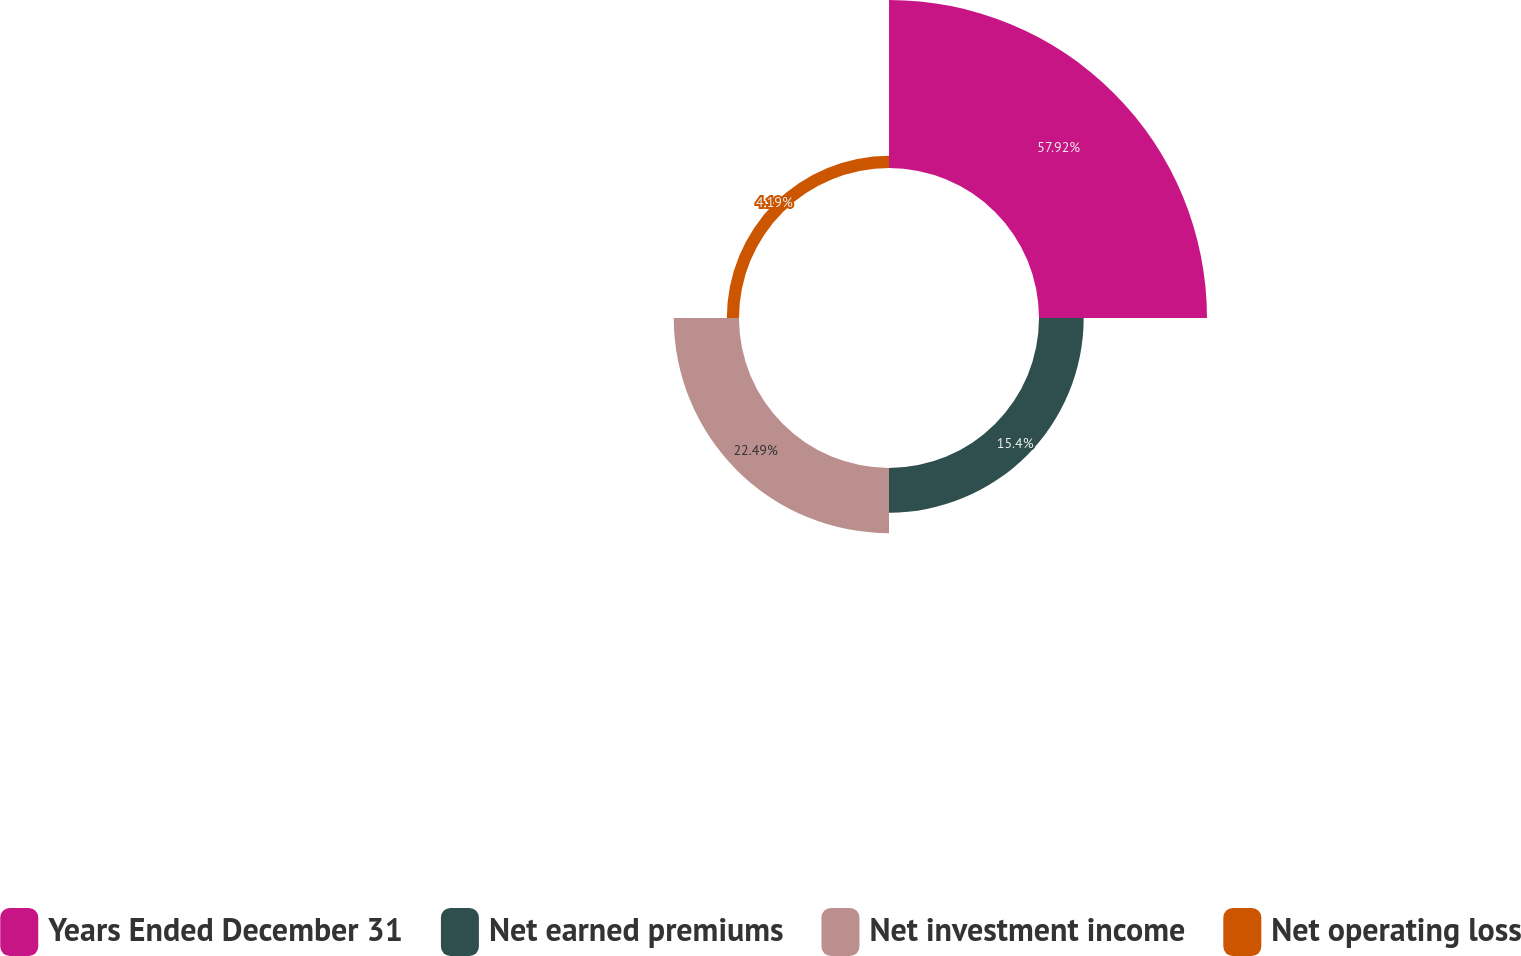Convert chart. <chart><loc_0><loc_0><loc_500><loc_500><pie_chart><fcel>Years Ended December 31<fcel>Net earned premiums<fcel>Net investment income<fcel>Net operating loss<nl><fcel>57.91%<fcel>15.4%<fcel>22.49%<fcel>4.19%<nl></chart> 